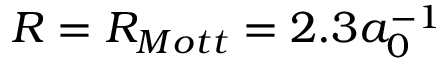<formula> <loc_0><loc_0><loc_500><loc_500>R = R _ { M o t t } = 2 . 3 a _ { 0 } ^ { - 1 }</formula> 